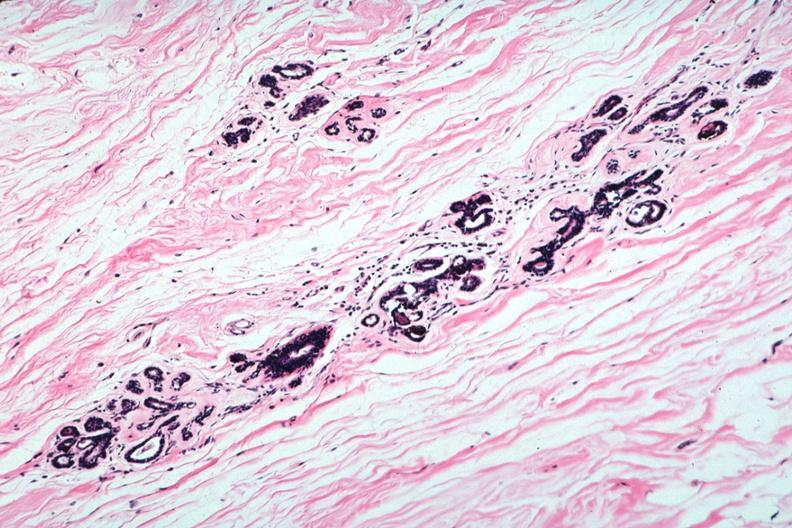what is present?
Answer the question using a single word or phrase. Atrophy 